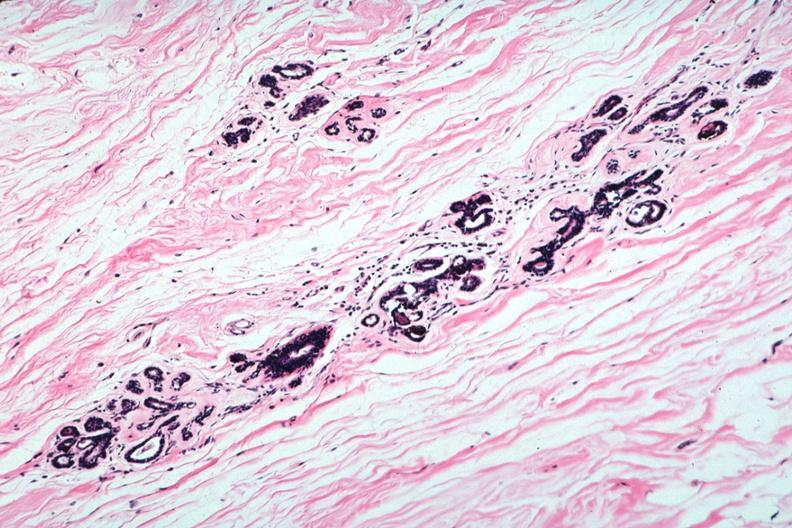what is present?
Answer the question using a single word or phrase. Atrophy 